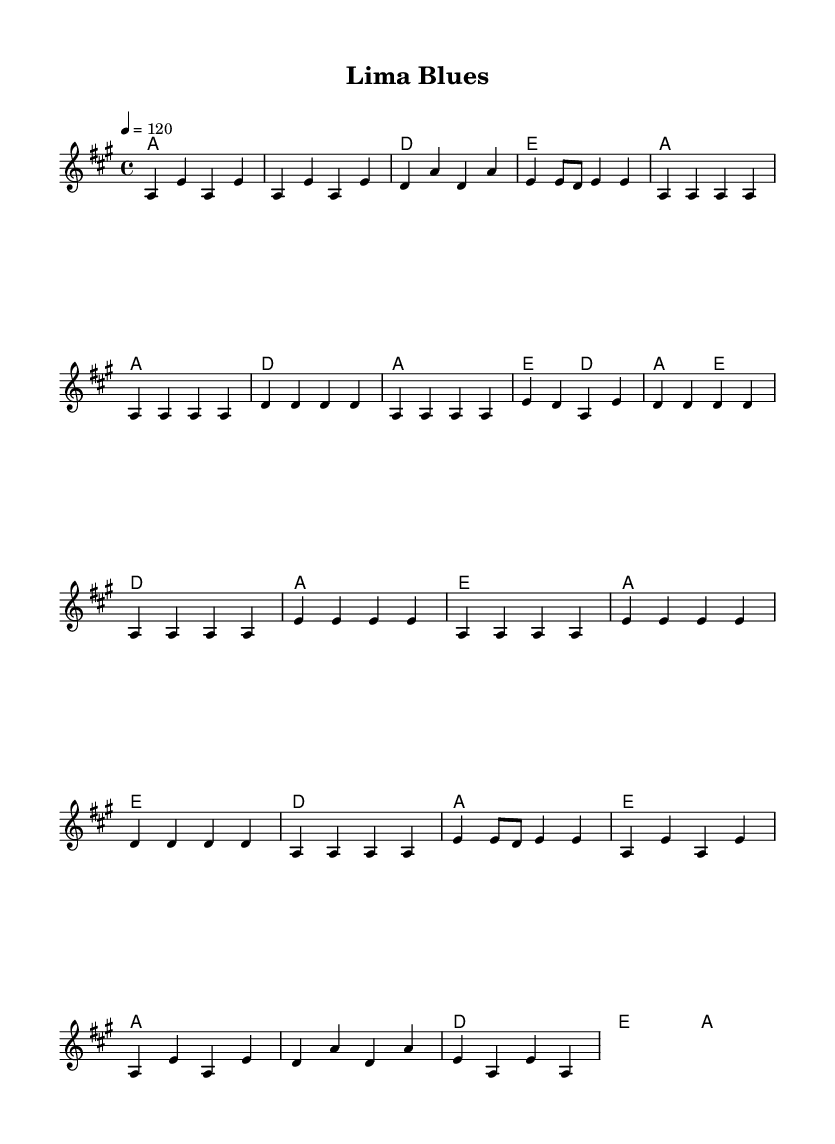What is the key signature of this music? The key signature indicates that the music is in A major, which has three sharps (F#, C#, and G#). This can be determined by looking at the key signature located at the beginning of the staff.
Answer: A major What is the time signature of this music? The time signature appears at the beginning of the score. It shows a “4/4” time signature, meaning there are four beats in each measure and a quarter note gets one beat.
Answer: 4/4 What is the tempo marking of this piece? The tempo marking is written above the staff as "4 = 120", indicating that a quarter note should be played at a speed of 120 beats per minute.
Answer: 120 What is the structure of this piece? By observing the different sections labeled in the music, such as "Intro", "Verse", "Chorus", "Bridge", and "Outro", it’s clear that the music follows an AABA structure typical of Electric Blues, with alternating choruses and verses.
Answer: AABA What chords are used in the Chorus? The chords in the Chorus section consist of D, A, E, repeated multiple times as identified in the chord names under the melody specifically for that section. This analysis involves checking the chord notation indicated during that part of the score.
Answer: D, A, E How many measures are in the Intro? Counting the measures specifically highlighted in the "Intro" section, you will see four distinct measures in total, which can be confirmed by examining the vertical lines separating each measure.
Answer: 4 What is the primary emotional theme of the piece? While not found directly in the notation, the title "Lima Blues" combined with the style suggests themes of cultural adjustment and longing, central to Electric Blues genre, which often explores deep emotional experiences.
Answer: Cultural adjustment 